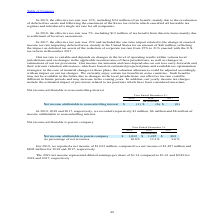According to Stmicroelectronics's financial document, How much net income represented diluted earnings per share in 2019? According to the financial document, $1.14. The relevant text states: "t income represented diluted earnings per share of $1.14 compared to $1.41 and $0.89 for 2018 and 2017, respectively...." Also, How much net income represented diluted earnings per share in 2018? According to the financial document, $1.41. The relevant text states: "ed diluted earnings per share of $1.14 compared to $1.41 and $0.89 for 2018 and 2017, respectively...." Also, How much net income represented diluted earnings per share in 2017? According to the financial document, $0.89. The relevant text states: "earnings per share of $1.14 compared to $1.41 and $0.89 for 2018 and 2017, respectively...." Also, can you calculate: What is the average net income attributable to parent company? To answer this question, I need to perform calculations using the financial data. The calculation is: (1,032+1,287+802) / 3, which equals 1040.33 (in millions). This is based on the information: "t income attributable to parent company $ 1,032 $ 1,287 $ 802 Net income attributable to parent company $ 1,032 $ 1,287 $ 802 attributable to parent company $ 1,032 $ 1,287 $ 802..." The key data points involved are: 1,032, 1,287, 802. Also, can you calculate: What is the increase/ (decrease) in net income attributable to parent company from 2018 to 2019? Based on the calculation: 1,032-1,287, the result is -255 (in millions). This is based on the information: "t income attributable to parent company $ 1,032 $ 1,287 $ 802 Net income attributable to parent company $ 1,032 $ 1,287 $ 802..." The key data points involved are: 1,032, 1,287. Also, can you calculate: What is the increase/ (decrease) in net income attributable to parent company from 2017 to 2018? Based on the calculation: 1,287-802 , the result is 485 (in millions). This is based on the information: "t income attributable to parent company $ 1,032 $ 1,287 $ 802 attributable to parent company $ 1,032 $ 1,287 $ 802..." The key data points involved are: 1,287, 802. 